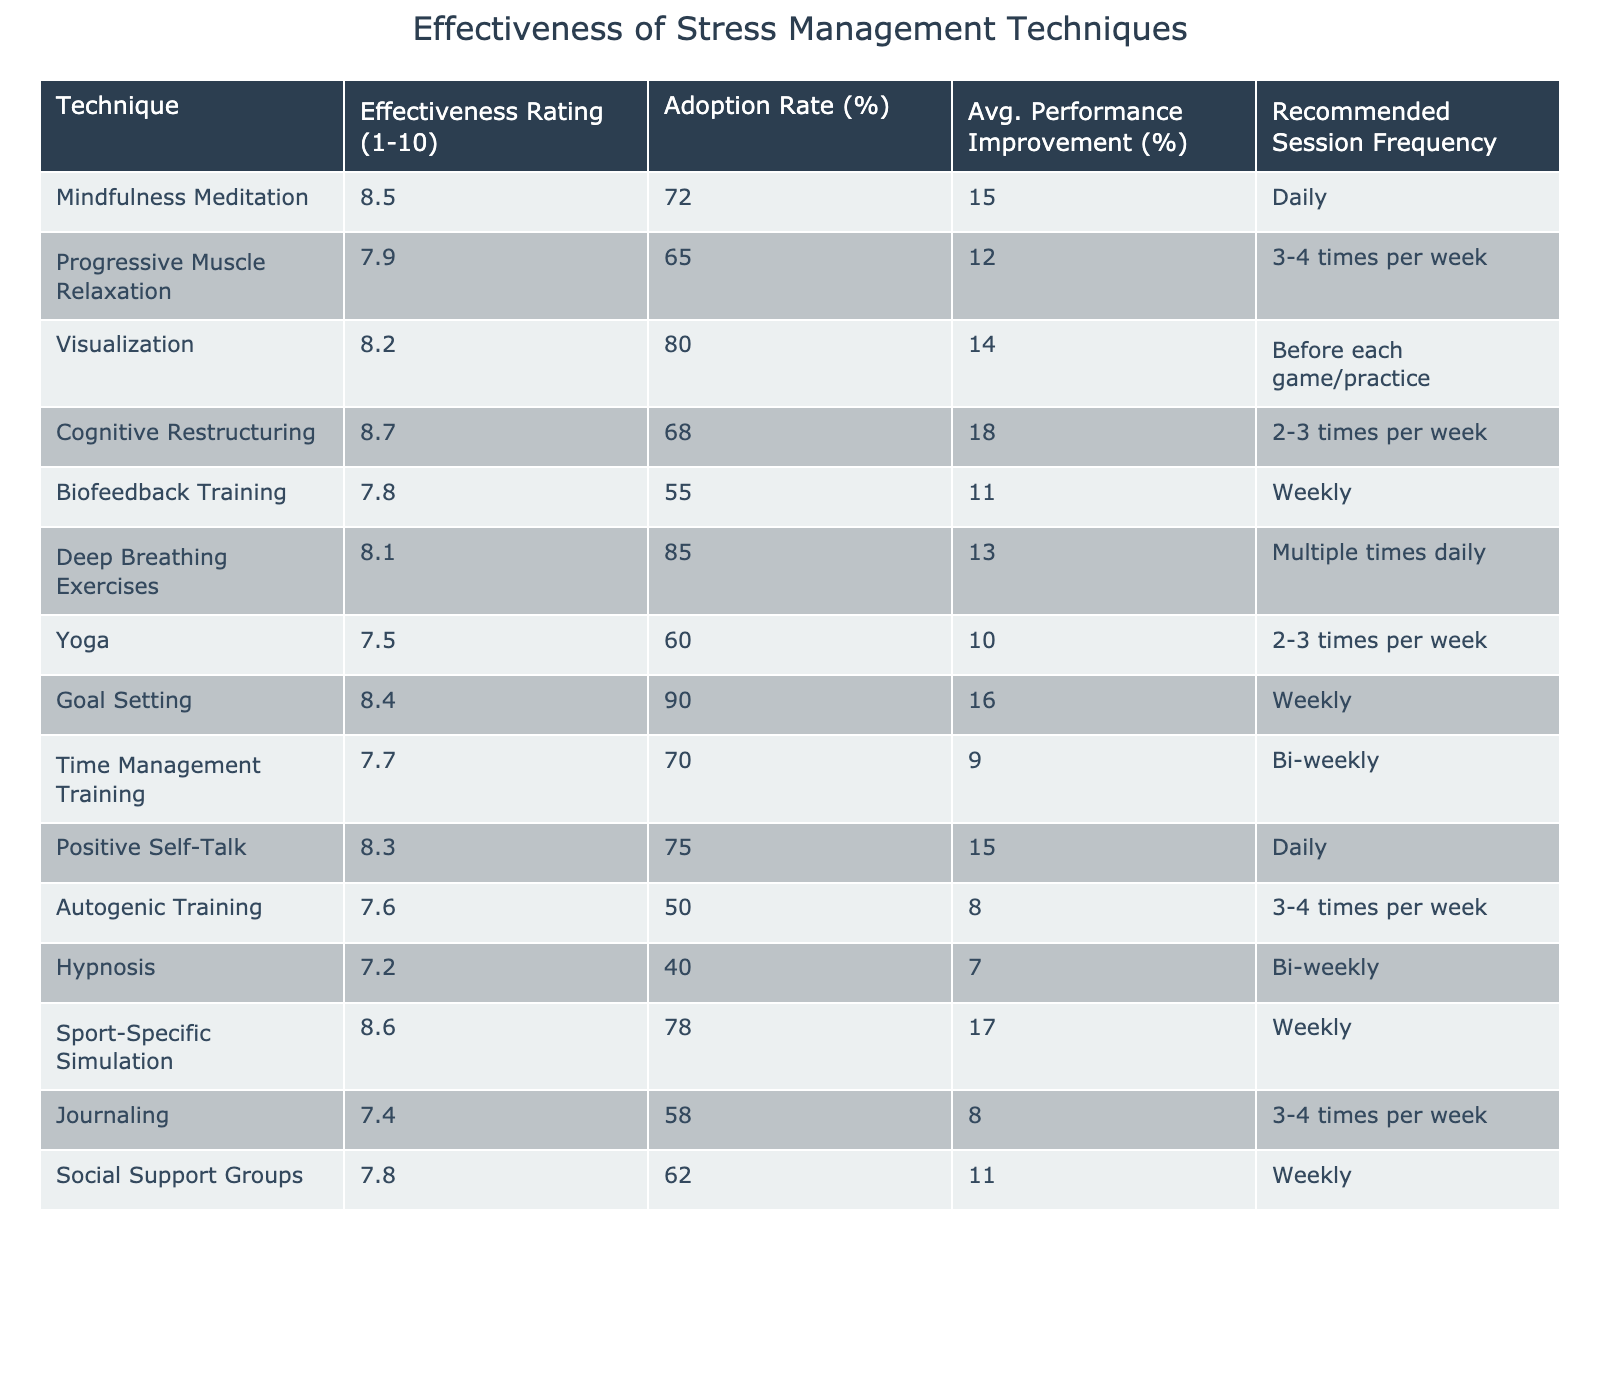What is the effectiveness rating of Mindfulness Meditation? The table lists the effectiveness rating for Mindfulness Meditation as 8.5, which is found under the "Effectiveness Rating (1-10)" column next to its technique name.
Answer: 8.5 Which technique has the highest adoption rate? The adoption rates for all techniques were compared, and Goal Setting has the highest adoption rate at 90%. This can be found under the "Adoption Rate (%)" column.
Answer: 90% What is the average performance improvement for Progressive Muscle Relaxation? The table shows the average performance improvement for Progressive Muscle Relaxation is 12%, located next to its technique name in the "Avg. Performance Improvement (%)" column.
Answer: 12% Is the effectiveness rating of Yoga greater than 8.0? By checking the table, Yoga has an effectiveness rating of 7.5, which is less than 8.0. Therefore, the statement is false.
Answer: No Which techniques have an effectiveness rating greater than 8.0 and are used daily? The table shows that Mindfulness Meditation (8.5) and Positive Self-Talk (8.3) both have effectiveness ratings greater than 8.0 and are recommended for daily use. Therefore, both techniques meet the criteria.
Answer: Mindfulness Meditation, Positive Self-Talk What is the average effectiveness rating for techniques that are recommended weekly? The techniques recommended weekly include Biofeedback Training (7.8), Goal Setting (8.4), Sport-Specific Simulation (8.6), and Social Support Groups (7.8). Their ratings are averaged as (7.8 + 8.4 + 8.6 + 7.8) / 4 = 8.15.
Answer: 8.15 Is there a technique with an effectiveness rating of 7.0 or lower? The table shows the rating for Hypnosis is 7.2, which falls below 8.0, indicating this technique meets the specified condition.
Answer: Yes What is the difference in performance improvement between Autogenic Training and Visualization? The averages for Autogenic Training (8%) and Visualization (14%) are subtracted: 14 - 8 = 6%. Thus, the difference in performance improvement between the two is 6%.
Answer: 6% How many techniques have an adoption rate of 70% or above? Upon reviewing the adoption rates for each technique, four techniques — Goal Setting (90%), Visualization (80%), Positive Self-Talk (75%), and Mindfulness Meditation (72%) — have rates of 70% or above, giving a total of four techniques.
Answer: 4 What is the trend in effectiveness ratings concerning recommended session frequency (more frequent to less frequent)? Reviewing the effectiveness ratings with respect to how frequently they should be practiced reveals a mixed trend. Techniques with daily recommendations score high (Mindfulness Meditation) compared to those with less frequency (e.g., Yoga at 7.5). A detailed evaluation would show higher ratings generally align with daily practice.
Answer: Mixed trend Which stress management technique has the lowest effectiveness rating? By examining the table, Autogenic Training has the lowest rating at 7.6, as seen under "Effectiveness Rating (1-10)" next to its technique name.
Answer: 7.6 